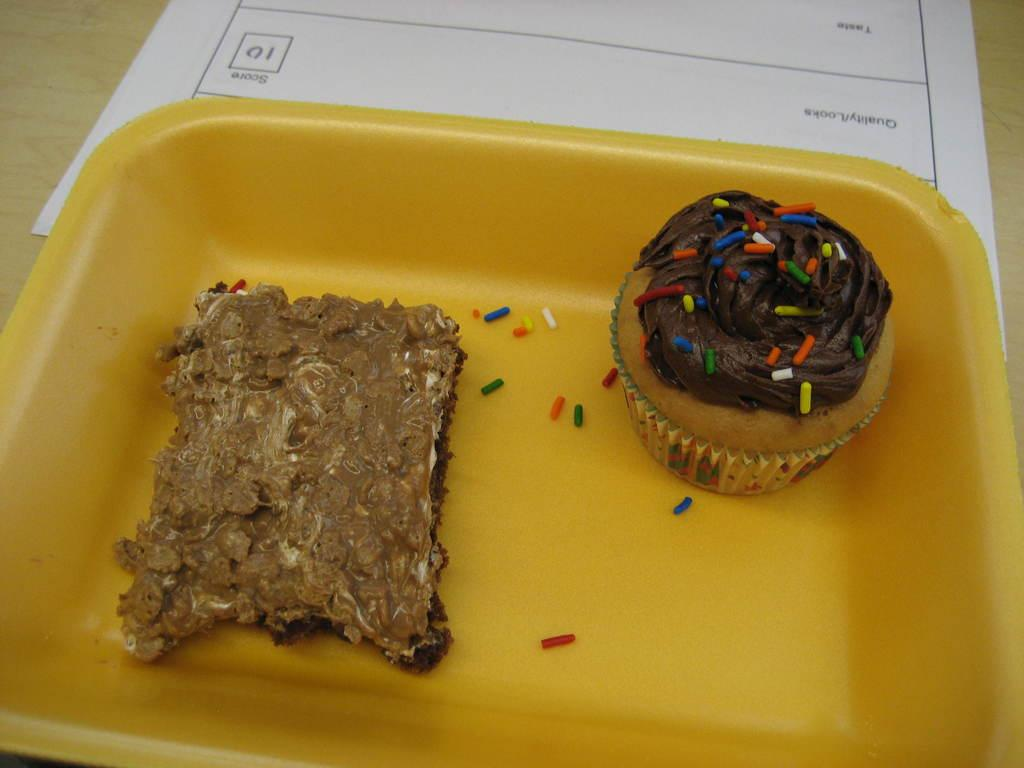What type of dessert is visible in the image? There is a cupcake in the image. What other food item can be seen in the image? There is a food item in a bowl in the image. What material is present in the image? There is paper in the image. Where are the cupcake, food item in a bowl, and paper located in the image? The cupcake, food item in a bowl, and paper are placed on a table. Can you tell me how many beads are scattered on the table in the image? There are no beads present in the image; only a cupcake, food item in a bowl, paper, and a table are visible. 